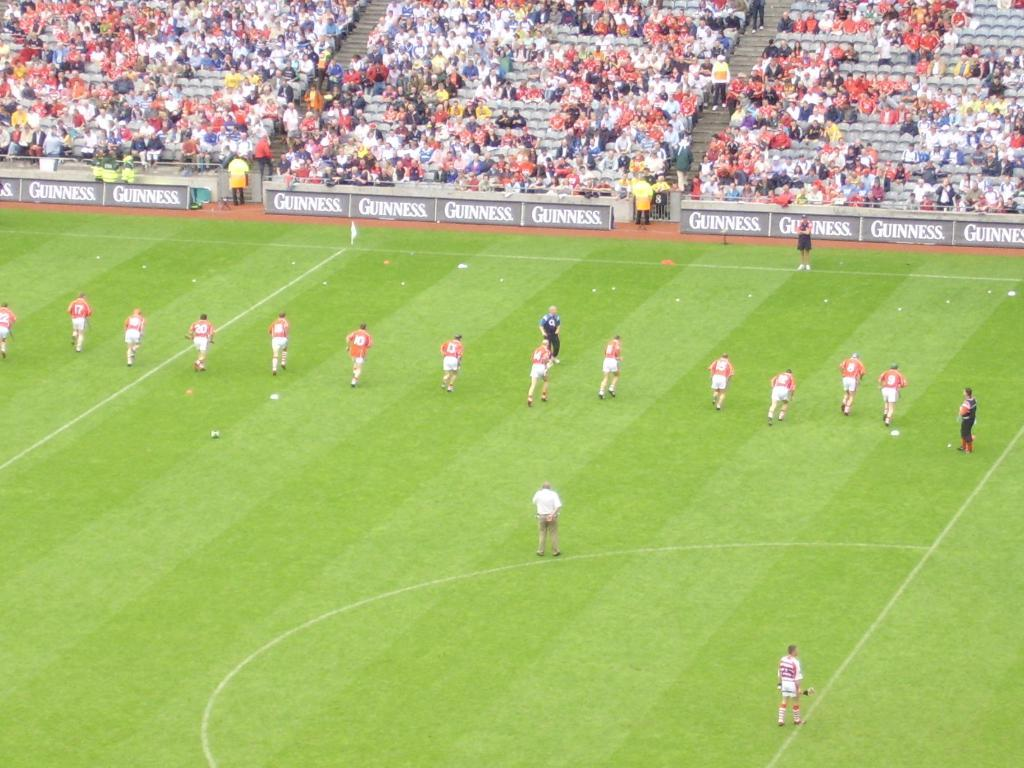<image>
Render a clear and concise summary of the photo. A team of players on a green field are running towards the Guinness banner below the stands where fans sit. 